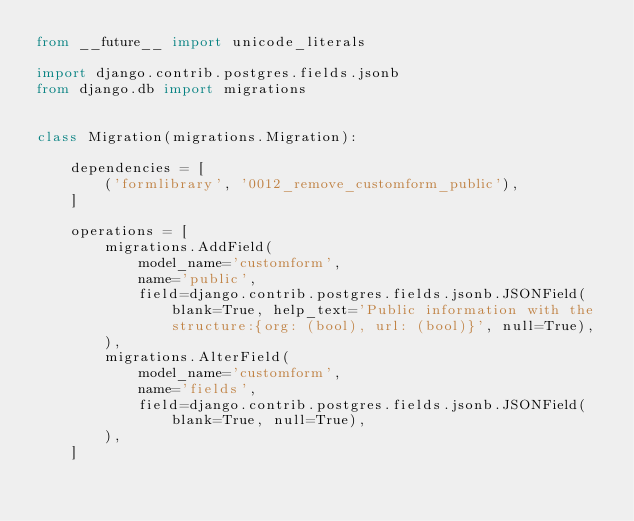<code> <loc_0><loc_0><loc_500><loc_500><_Python_>from __future__ import unicode_literals

import django.contrib.postgres.fields.jsonb
from django.db import migrations


class Migration(migrations.Migration):

    dependencies = [
        ('formlibrary', '0012_remove_customform_public'),
    ]

    operations = [
        migrations.AddField(
            model_name='customform',
            name='public',
            field=django.contrib.postgres.fields.jsonb.JSONField(blank=True, help_text='Public information with the structure:{org: (bool), url: (bool)}', null=True),
        ),
        migrations.AlterField(
            model_name='customform',
            name='fields',
            field=django.contrib.postgres.fields.jsonb.JSONField(blank=True, null=True),
        ),
    ]
</code> 